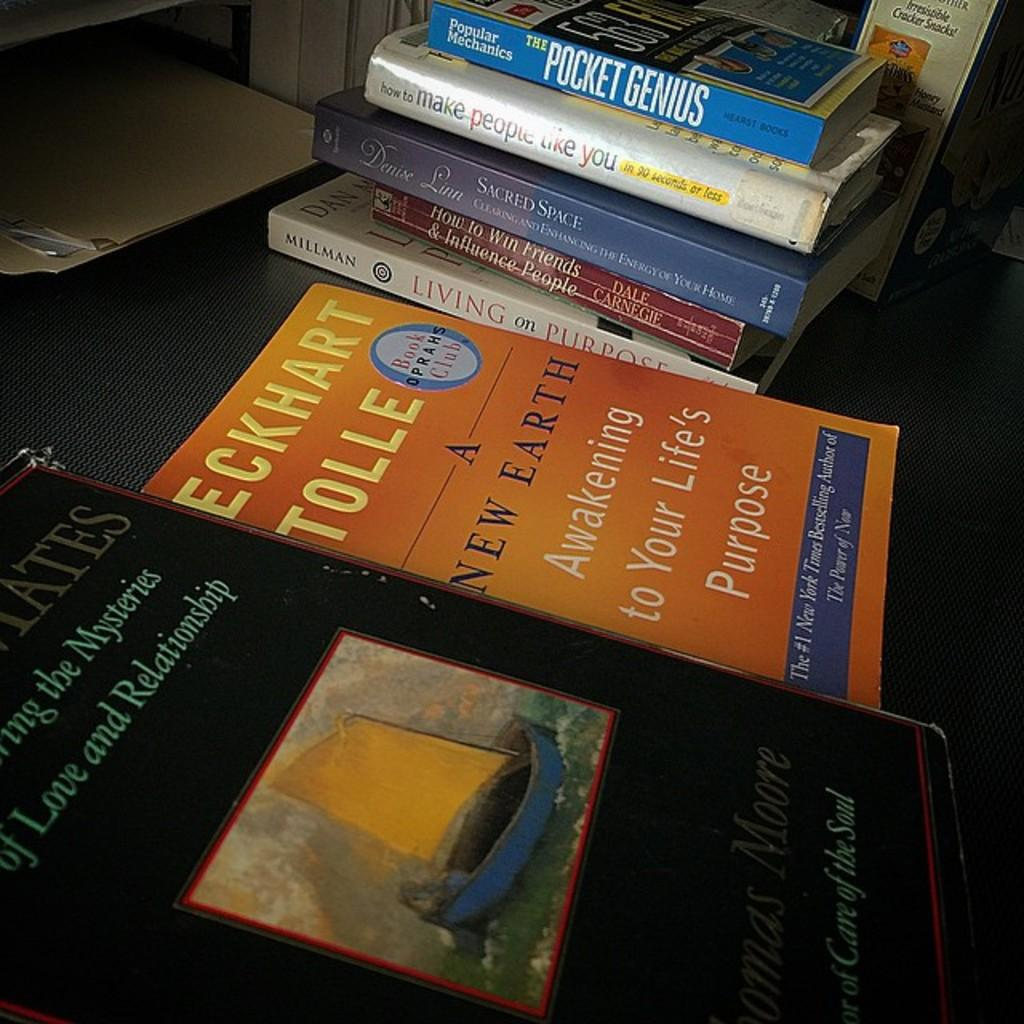<image>
Offer a succinct explanation of the picture presented. stacks of books with one of them called 'a new earth awakening to your life's purpose' 